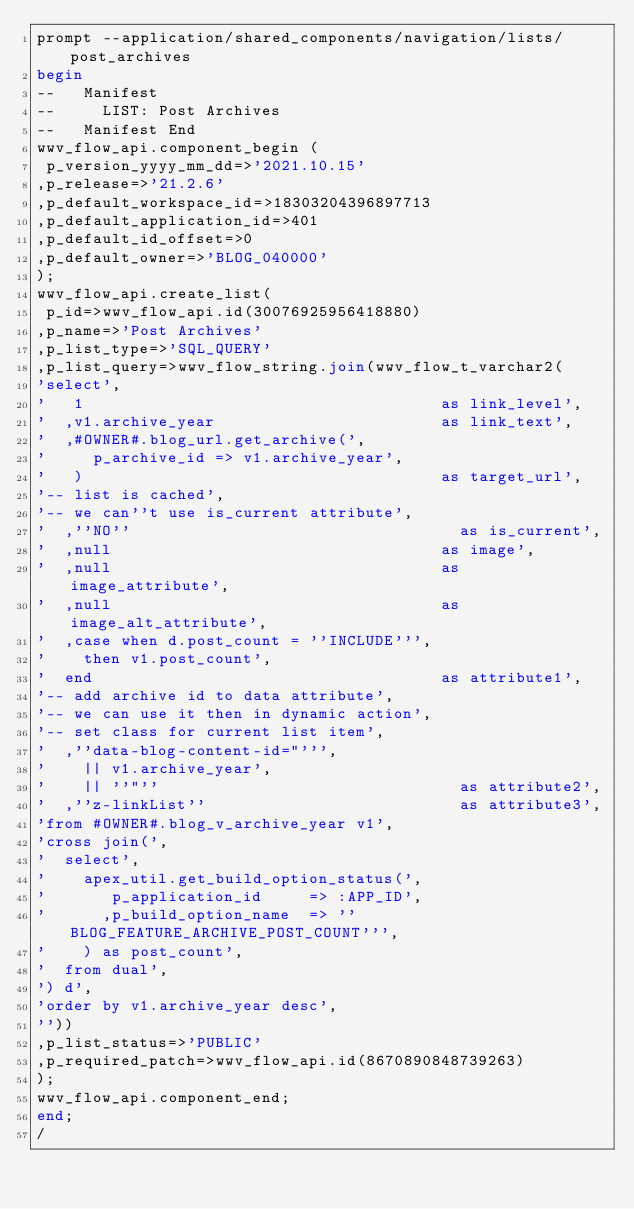<code> <loc_0><loc_0><loc_500><loc_500><_SQL_>prompt --application/shared_components/navigation/lists/post_archives
begin
--   Manifest
--     LIST: Post Archives
--   Manifest End
wwv_flow_api.component_begin (
 p_version_yyyy_mm_dd=>'2021.10.15'
,p_release=>'21.2.6'
,p_default_workspace_id=>18303204396897713
,p_default_application_id=>401
,p_default_id_offset=>0
,p_default_owner=>'BLOG_040000'
);
wwv_flow_api.create_list(
 p_id=>wwv_flow_api.id(30076925956418880)
,p_name=>'Post Archives'
,p_list_type=>'SQL_QUERY'
,p_list_query=>wwv_flow_string.join(wwv_flow_t_varchar2(
'select',
'   1                                      as link_level',
'  ,v1.archive_year                        as link_text',
'  ,#OWNER#.blog_url.get_archive(',
'     p_archive_id => v1.archive_year',
'   )                                      as target_url',
'-- list is cached',
'-- we can''t use is_current attribute',
'  ,''NO''                                   as is_current',
'  ,null                                   as image',
'  ,null                                   as image_attribute',
'  ,null                                   as image_alt_attribute',
'  ,case when d.post_count = ''INCLUDE''',
'    then v1.post_count',
'  end                                     as attribute1',
'-- add archive id to data attribute',
'-- we can use it then in dynamic action',
'-- set class for current list item',
'  ,''data-blog-content-id="''',
'    || v1.archive_year',
'    || ''"''                                as attribute2',
'  ,''z-linkList''                           as attribute3',
'from #OWNER#.blog_v_archive_year v1',
'cross join(',
'  select',
'    apex_util.get_build_option_status(',
'       p_application_id     => :APP_ID',
'      ,p_build_option_name  => ''BLOG_FEATURE_ARCHIVE_POST_COUNT''',
'    ) as post_count',
'  from dual',
') d',
'order by v1.archive_year desc',
''))
,p_list_status=>'PUBLIC'
,p_required_patch=>wwv_flow_api.id(8670890848739263)
);
wwv_flow_api.component_end;
end;
/
</code> 